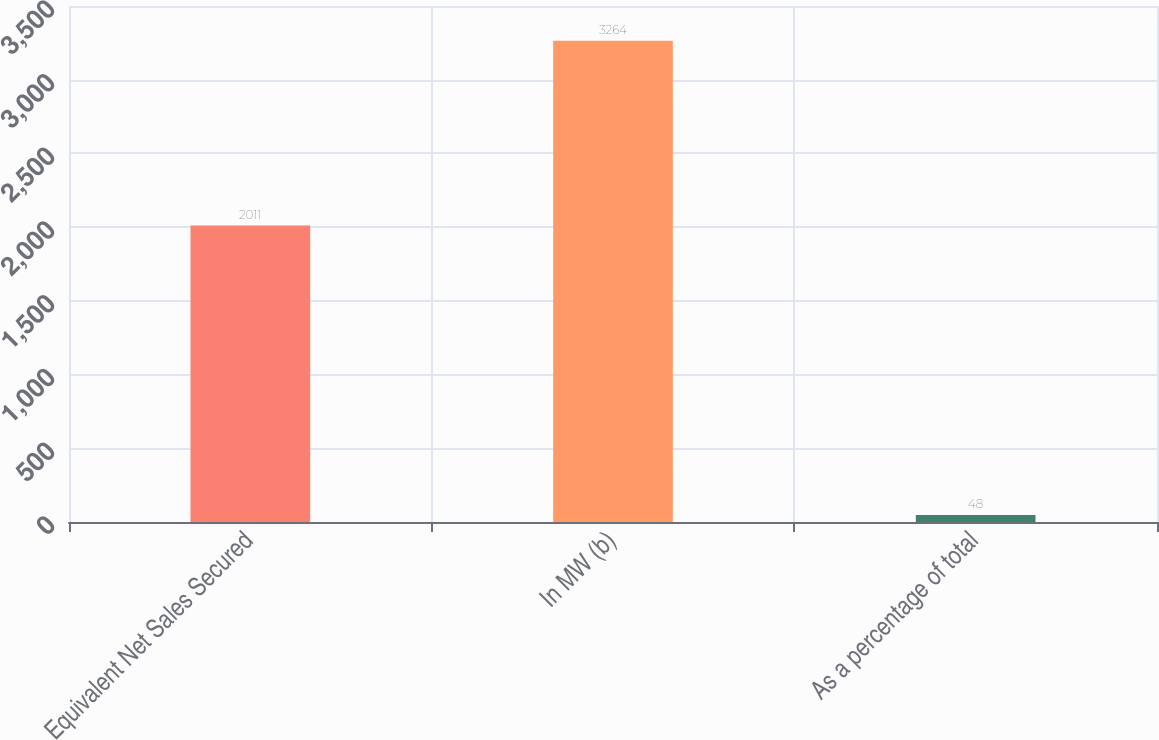Convert chart to OTSL. <chart><loc_0><loc_0><loc_500><loc_500><bar_chart><fcel>Equivalent Net Sales Secured<fcel>In MW (b)<fcel>As a percentage of total<nl><fcel>2011<fcel>3264<fcel>48<nl></chart> 